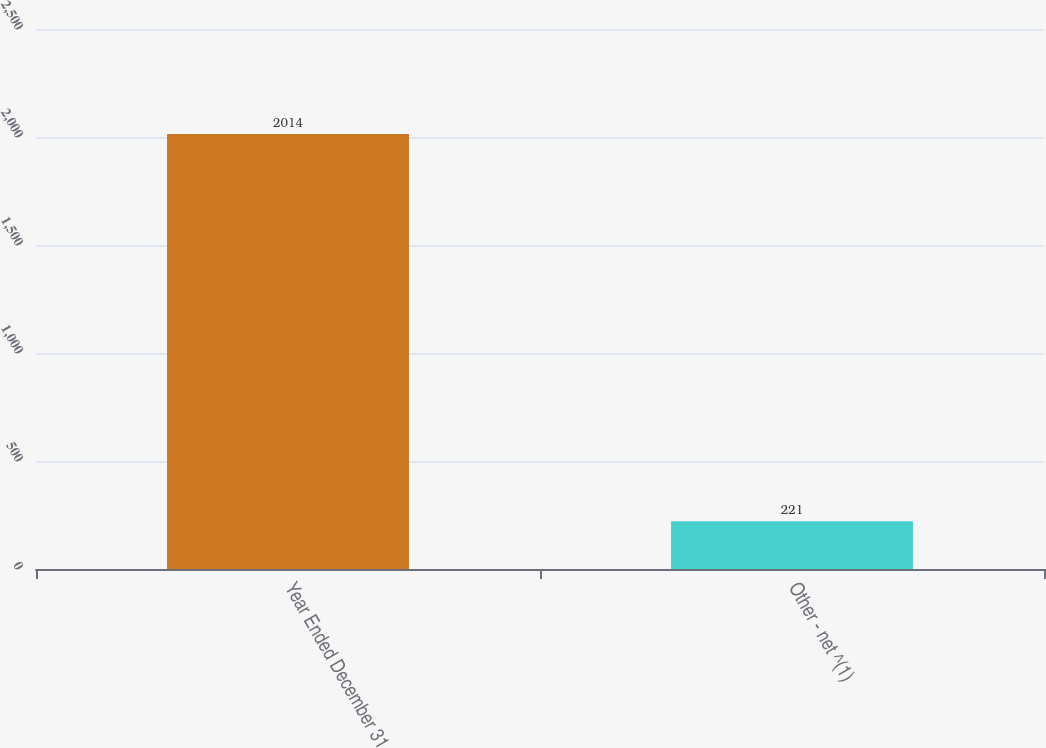Convert chart. <chart><loc_0><loc_0><loc_500><loc_500><bar_chart><fcel>Year Ended December 31<fcel>Other - net ^(1)<nl><fcel>2014<fcel>221<nl></chart> 